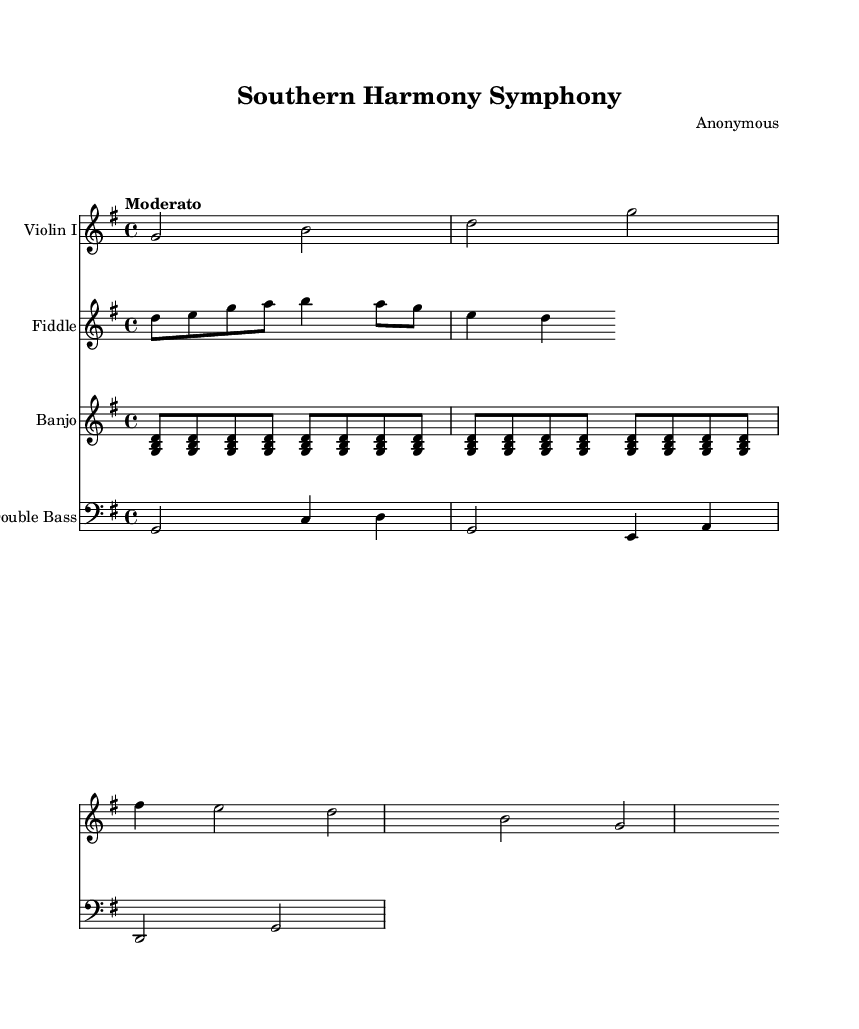What is the key signature of this music? The key signature is G major, which has one sharp (F#). This can be identified by looking at the key signature clef at the beginning of the sheet music where one sharp is displayed.
Answer: G major What is the time signature of this music? The time signature is 4/4, indicated at the beginning of the score. This means there are four beats in each measure, and a quarter note receives one beat.
Answer: 4/4 What is the tempo marking for this piece? The tempo marking is Moderato. This is stated at the beginning of the music, indicating a moderate speed at which the piece should be performed.
Answer: Moderato What instrument is labeled as "Fiddle"? The Fiddle is the string instrument part that plays alongside the Violin I. Its staff appears in the score specifically labeled as such.
Answer: Fiddle How many measures are in the violin part? The violin part consists of a total of two measures. This can be counted by looking at the bar lines that divide the notation into sections.
Answer: 2 What kind of musical elements are used in the fiddle part? The fiddle part utilizes eighth notes and a combination of quarter notes, which often reflects traditional Southern gospel and bluegrass styles through its rhythmic and melodic structure.
Answer: Eighth notes and quarter notes What repeating pattern is used in the banjo part? The banjo part has a repeating pattern of eighth-note chords played in the structure of a triplet sequence over four measures. This reflects the characteristic strumming pattern commonly found in bluegrass music.
Answer: Repeating eighth-note chords 